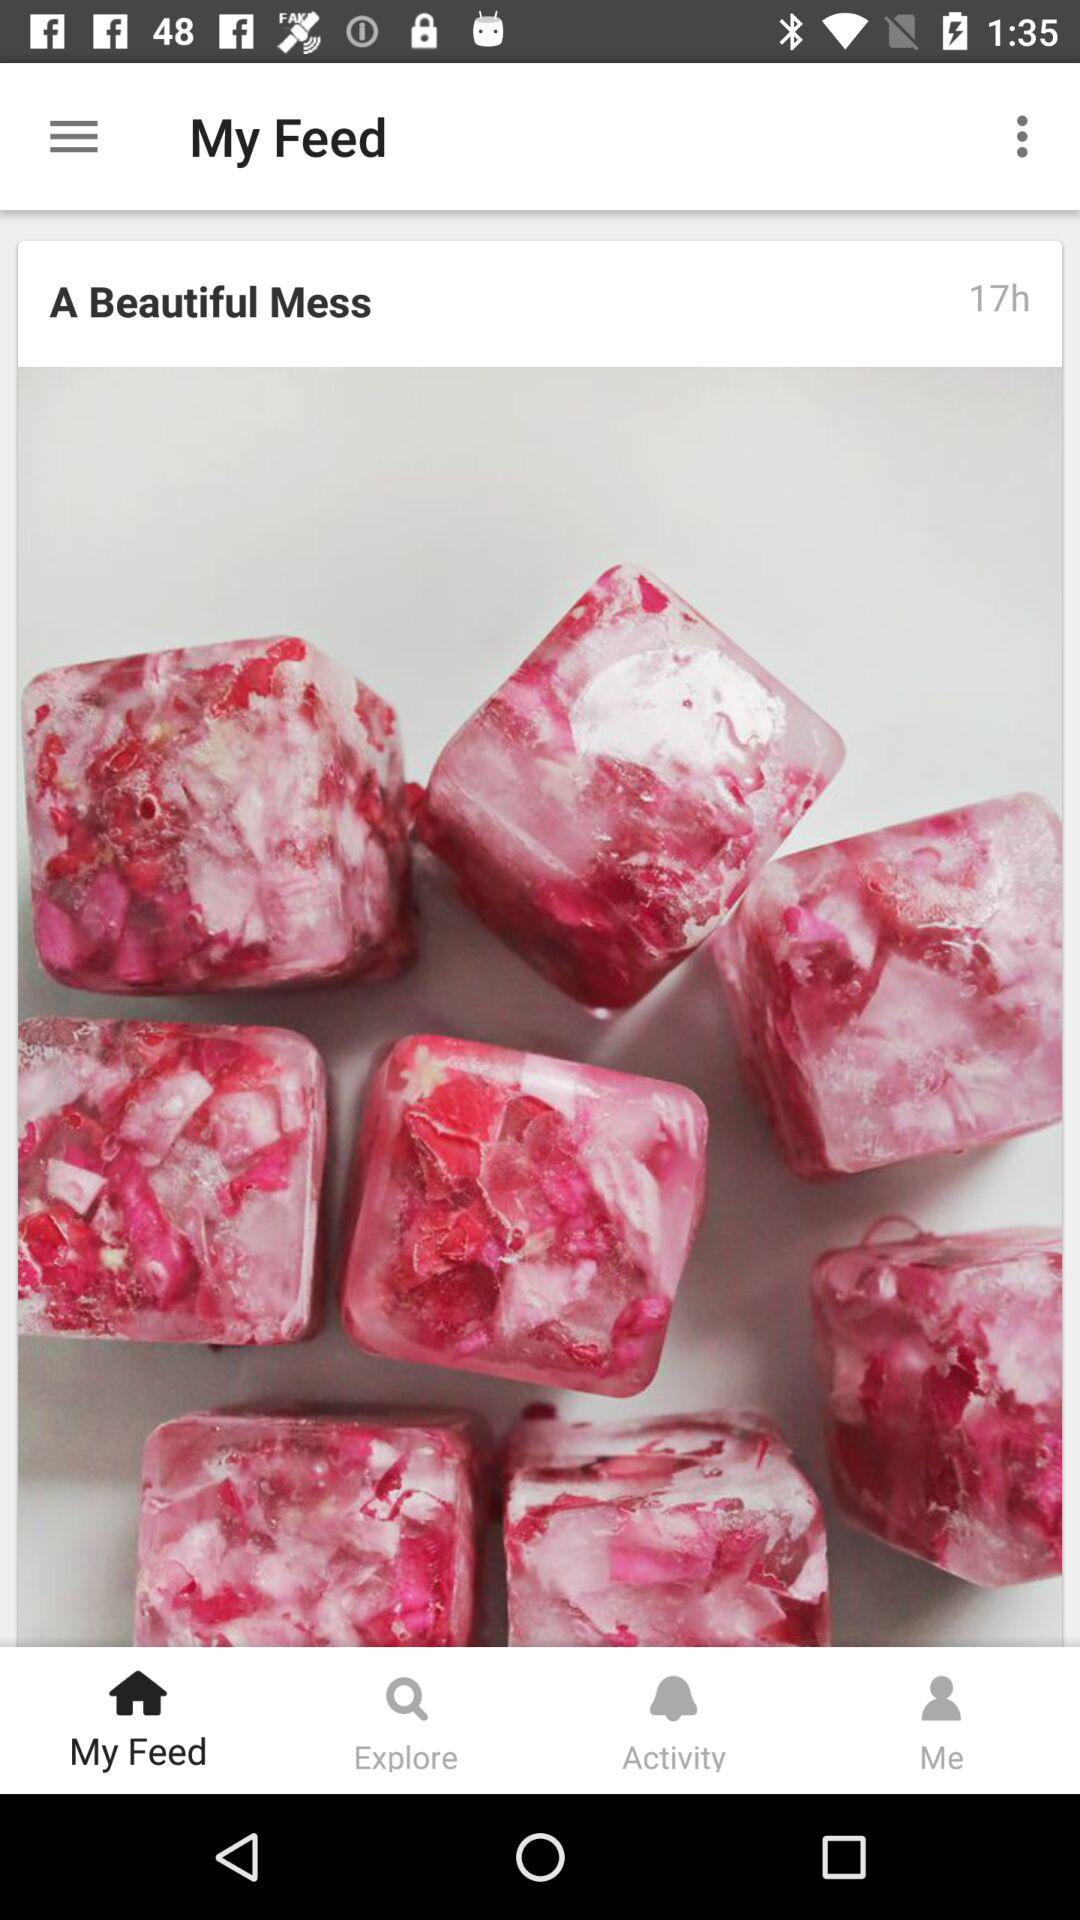What is the selected tab? The selected tab is "My Feed". 